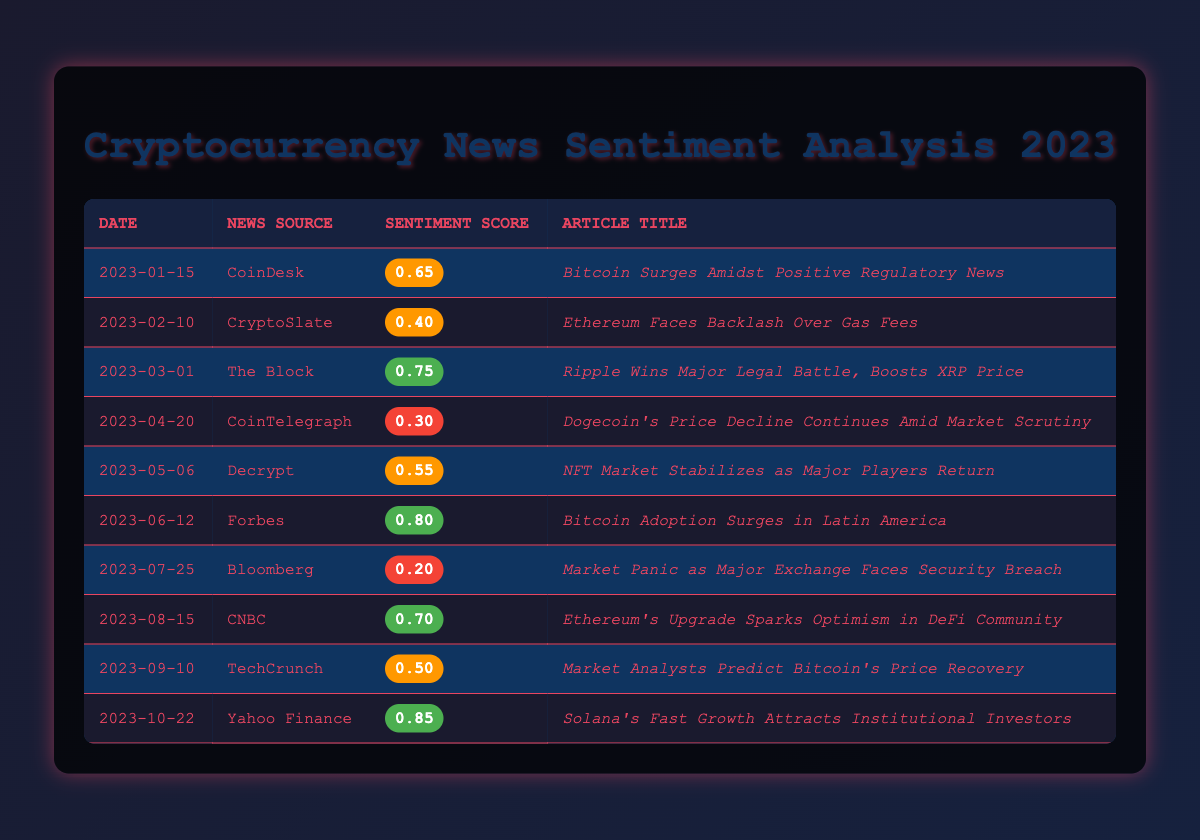What is the highest sentiment score in the table? The table lists various sentiment scores, and upon inspection, the highest score is 0.85, corresponding to the article titled "Solana's Fast Growth Attracts Institutional Investors."
Answer: 0.85 Which article received the lowest sentiment score? Looking through the sentiment scores, the lowest score of 0.20 is attributed to the article titled "Market Panic as Major Exchange Faces Security Breach."
Answer: "Market Panic as Major Exchange Faces Security Breach" How many articles have a sentiment score above 0.7? The articles with scores above 0.7 are "Ripple Wins Major Legal Battle, Boosts XRP Price" (0.75), "Bitcoin Adoption Surges in Latin America" (0.80), "Ethereum's Upgrade Sparks Optimism in DeFi Community" (0.70), and "Solana's Fast Growth Attracts Institutional Investors" (0.85). In total, there are 4 such articles.
Answer: 4 What is the average sentiment score of all the articles? To find the average, first sum all the sentiment scores (0.65 + 0.40 + 0.75 + 0.30 + 0.55 + 0.80 + 0.20 + 0.70 + 0.50 + 0.85 = 5.30). Then divide the total by the number of articles (10), giving an average score of 5.30 / 10 = 0.53.
Answer: 0.53 Is there an article from CoinDesk with a sentiment score above 0.6? The article titled "Bitcoin Surges Amidst Positive Regulatory News" from CoinDesk has a sentiment score of 0.65, which is above 0.6. Therefore, the statement is true.
Answer: Yes What is the difference in sentiment scores between the highest and lowest articles? The highest score is 0.85 (for "Solana's Fast Growth Attracts Institutional Investors") and the lowest is 0.20 (for "Market Panic as Major Exchange Faces Security Breach"). The difference is 0.85 - 0.20 = 0.65.
Answer: 0.65 Which month had the most articles with scores categorized as low? Reviewing the data, the only low score (0.20) is from July and another low score (0.30) is from April. Each month has 1 low score, so July has the most articles categorized as low.
Answer: July Were there any articles published in June or July with a sentiment score above 0.6? In June, "Bitcoin Adoption Surges in Latin America" has a score of 0.80, which is above 0.6. In July, there is only the article with a score of 0.20. Thus, the statement is true based on the June article.
Answer: Yes What percentage of the articles in the table has a sentiment score less than 0.5? The articles with a score below 0.5 are "Ethereum Faces Backlash Over Gas Fees" (0.40), "Dogecoin's Price Decline Continues Amid Market Scrutiny" (0.30), and "Market Panic as Major Exchange Faces Security Breach" (0.20), totaling 3 articles. There are 10 articles overall, so the percentage is (3/10) * 100 = 30%.
Answer: 30% 